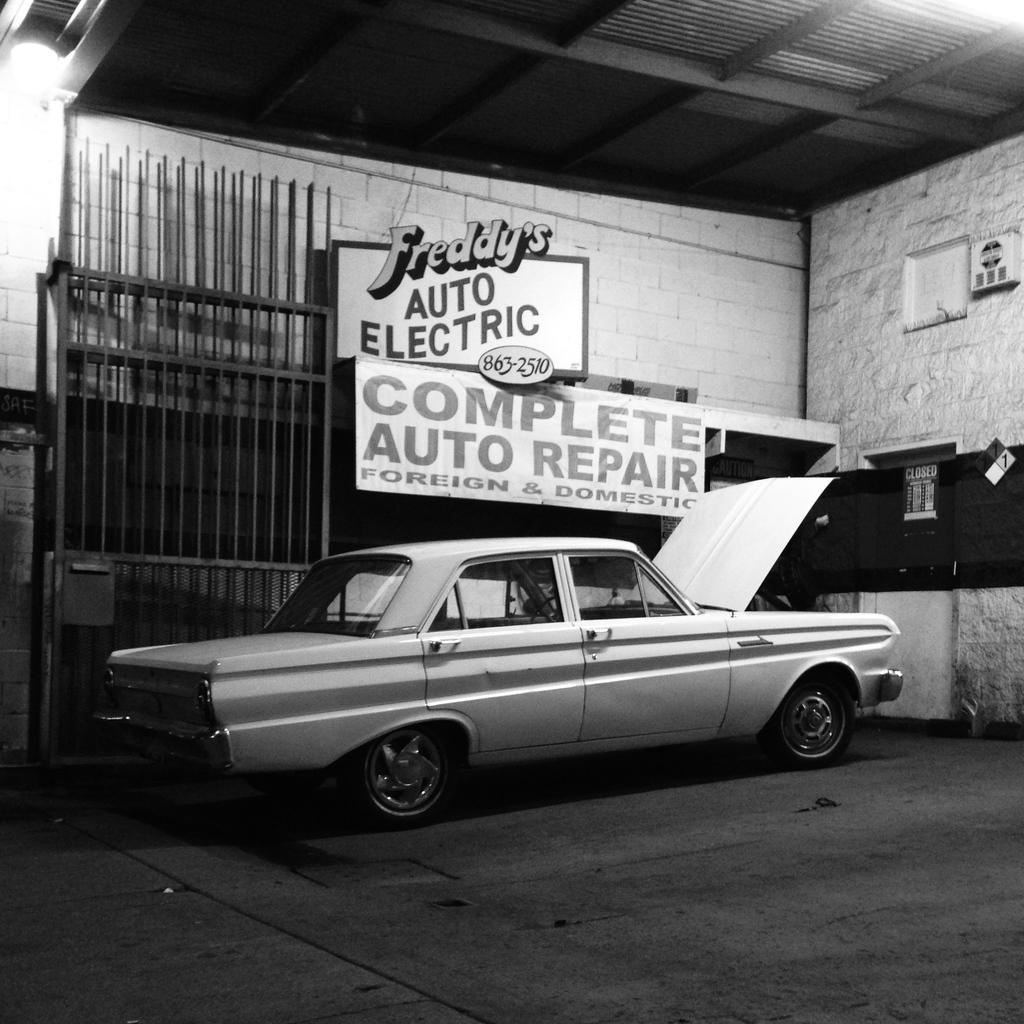What is the main subject of the image? The main subject of the image is a car. Where is the car located? The car is in a garage. Can you describe the garage? The garage has a big gate. What type of advertisement can be seen on the car in the image? There is no advertisement visible on the car in the image. Can you spot a giraffe in the garage with the car? There is no giraffe present in the image. 